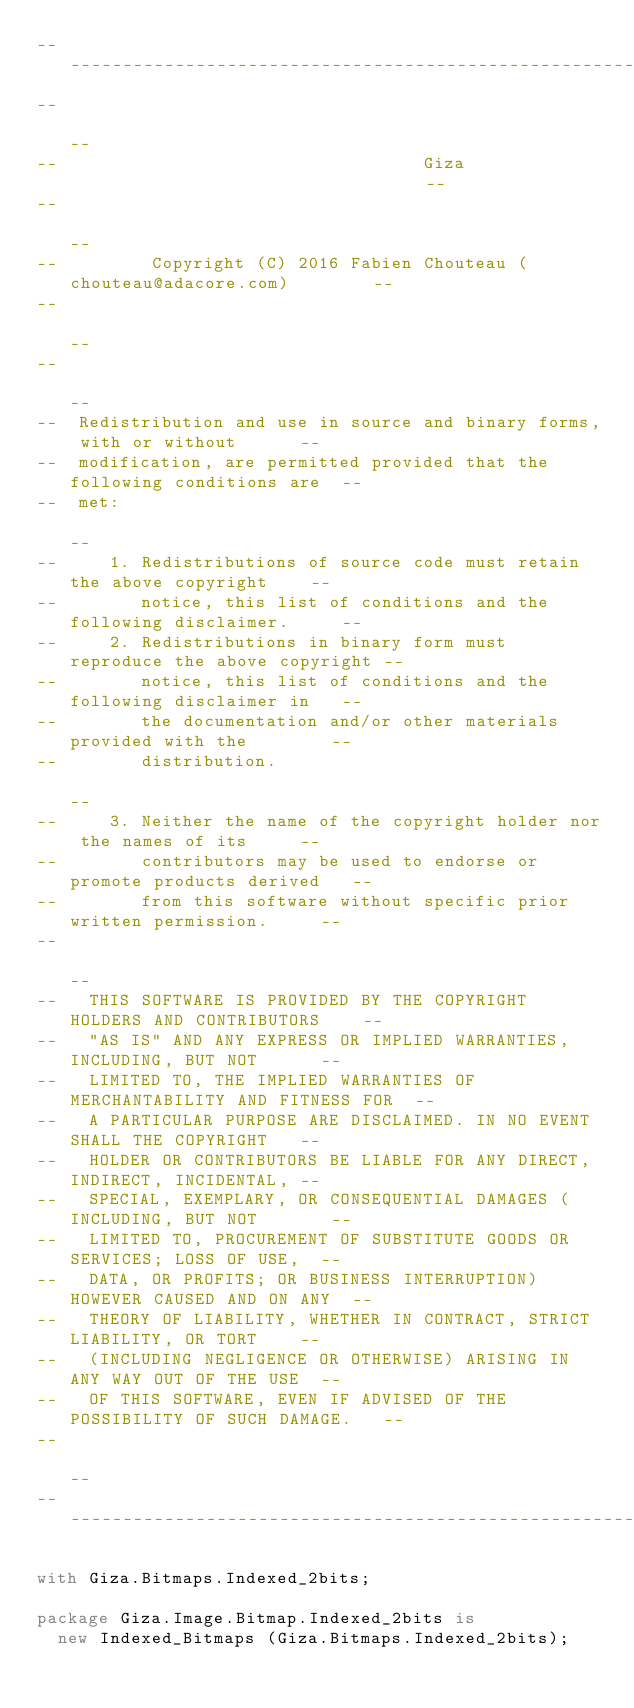<code> <loc_0><loc_0><loc_500><loc_500><_Ada_>------------------------------------------------------------------------------
--                                                                          --
--                                   Giza                                   --
--                                                                          --
--         Copyright (C) 2016 Fabien Chouteau (chouteau@adacore.com)        --
--                                                                          --
--                                                                          --
--  Redistribution and use in source and binary forms, with or without      --
--  modification, are permitted provided that the following conditions are  --
--  met:                                                                    --
--     1. Redistributions of source code must retain the above copyright    --
--        notice, this list of conditions and the following disclaimer.     --
--     2. Redistributions in binary form must reproduce the above copyright --
--        notice, this list of conditions and the following disclaimer in   --
--        the documentation and/or other materials provided with the        --
--        distribution.                                                     --
--     3. Neither the name of the copyright holder nor the names of its     --
--        contributors may be used to endorse or promote products derived   --
--        from this software without specific prior written permission.     --
--                                                                          --
--   THIS SOFTWARE IS PROVIDED BY THE COPYRIGHT HOLDERS AND CONTRIBUTORS    --
--   "AS IS" AND ANY EXPRESS OR IMPLIED WARRANTIES, INCLUDING, BUT NOT      --
--   LIMITED TO, THE IMPLIED WARRANTIES OF MERCHANTABILITY AND FITNESS FOR  --
--   A PARTICULAR PURPOSE ARE DISCLAIMED. IN NO EVENT SHALL THE COPYRIGHT   --
--   HOLDER OR CONTRIBUTORS BE LIABLE FOR ANY DIRECT, INDIRECT, INCIDENTAL, --
--   SPECIAL, EXEMPLARY, OR CONSEQUENTIAL DAMAGES (INCLUDING, BUT NOT       --
--   LIMITED TO, PROCUREMENT OF SUBSTITUTE GOODS OR SERVICES; LOSS OF USE,  --
--   DATA, OR PROFITS; OR BUSINESS INTERRUPTION) HOWEVER CAUSED AND ON ANY  --
--   THEORY OF LIABILITY, WHETHER IN CONTRACT, STRICT LIABILITY, OR TORT    --
--   (INCLUDING NEGLIGENCE OR OTHERWISE) ARISING IN ANY WAY OUT OF THE USE  --
--   OF THIS SOFTWARE, EVEN IF ADVISED OF THE POSSIBILITY OF SUCH DAMAGE.   --
--                                                                          --
------------------------------------------------------------------------------

with Giza.Bitmaps.Indexed_2bits;

package Giza.Image.Bitmap.Indexed_2bits is
  new Indexed_Bitmaps (Giza.Bitmaps.Indexed_2bits);
</code> 